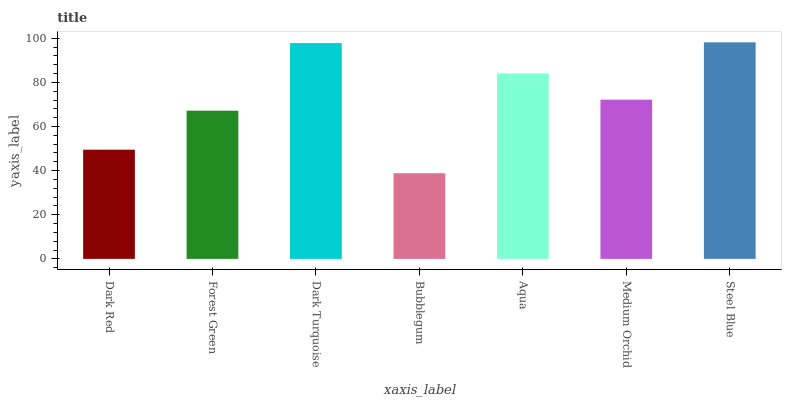Is Bubblegum the minimum?
Answer yes or no. Yes. Is Steel Blue the maximum?
Answer yes or no. Yes. Is Forest Green the minimum?
Answer yes or no. No. Is Forest Green the maximum?
Answer yes or no. No. Is Forest Green greater than Dark Red?
Answer yes or no. Yes. Is Dark Red less than Forest Green?
Answer yes or no. Yes. Is Dark Red greater than Forest Green?
Answer yes or no. No. Is Forest Green less than Dark Red?
Answer yes or no. No. Is Medium Orchid the high median?
Answer yes or no. Yes. Is Medium Orchid the low median?
Answer yes or no. Yes. Is Dark Turquoise the high median?
Answer yes or no. No. Is Dark Red the low median?
Answer yes or no. No. 